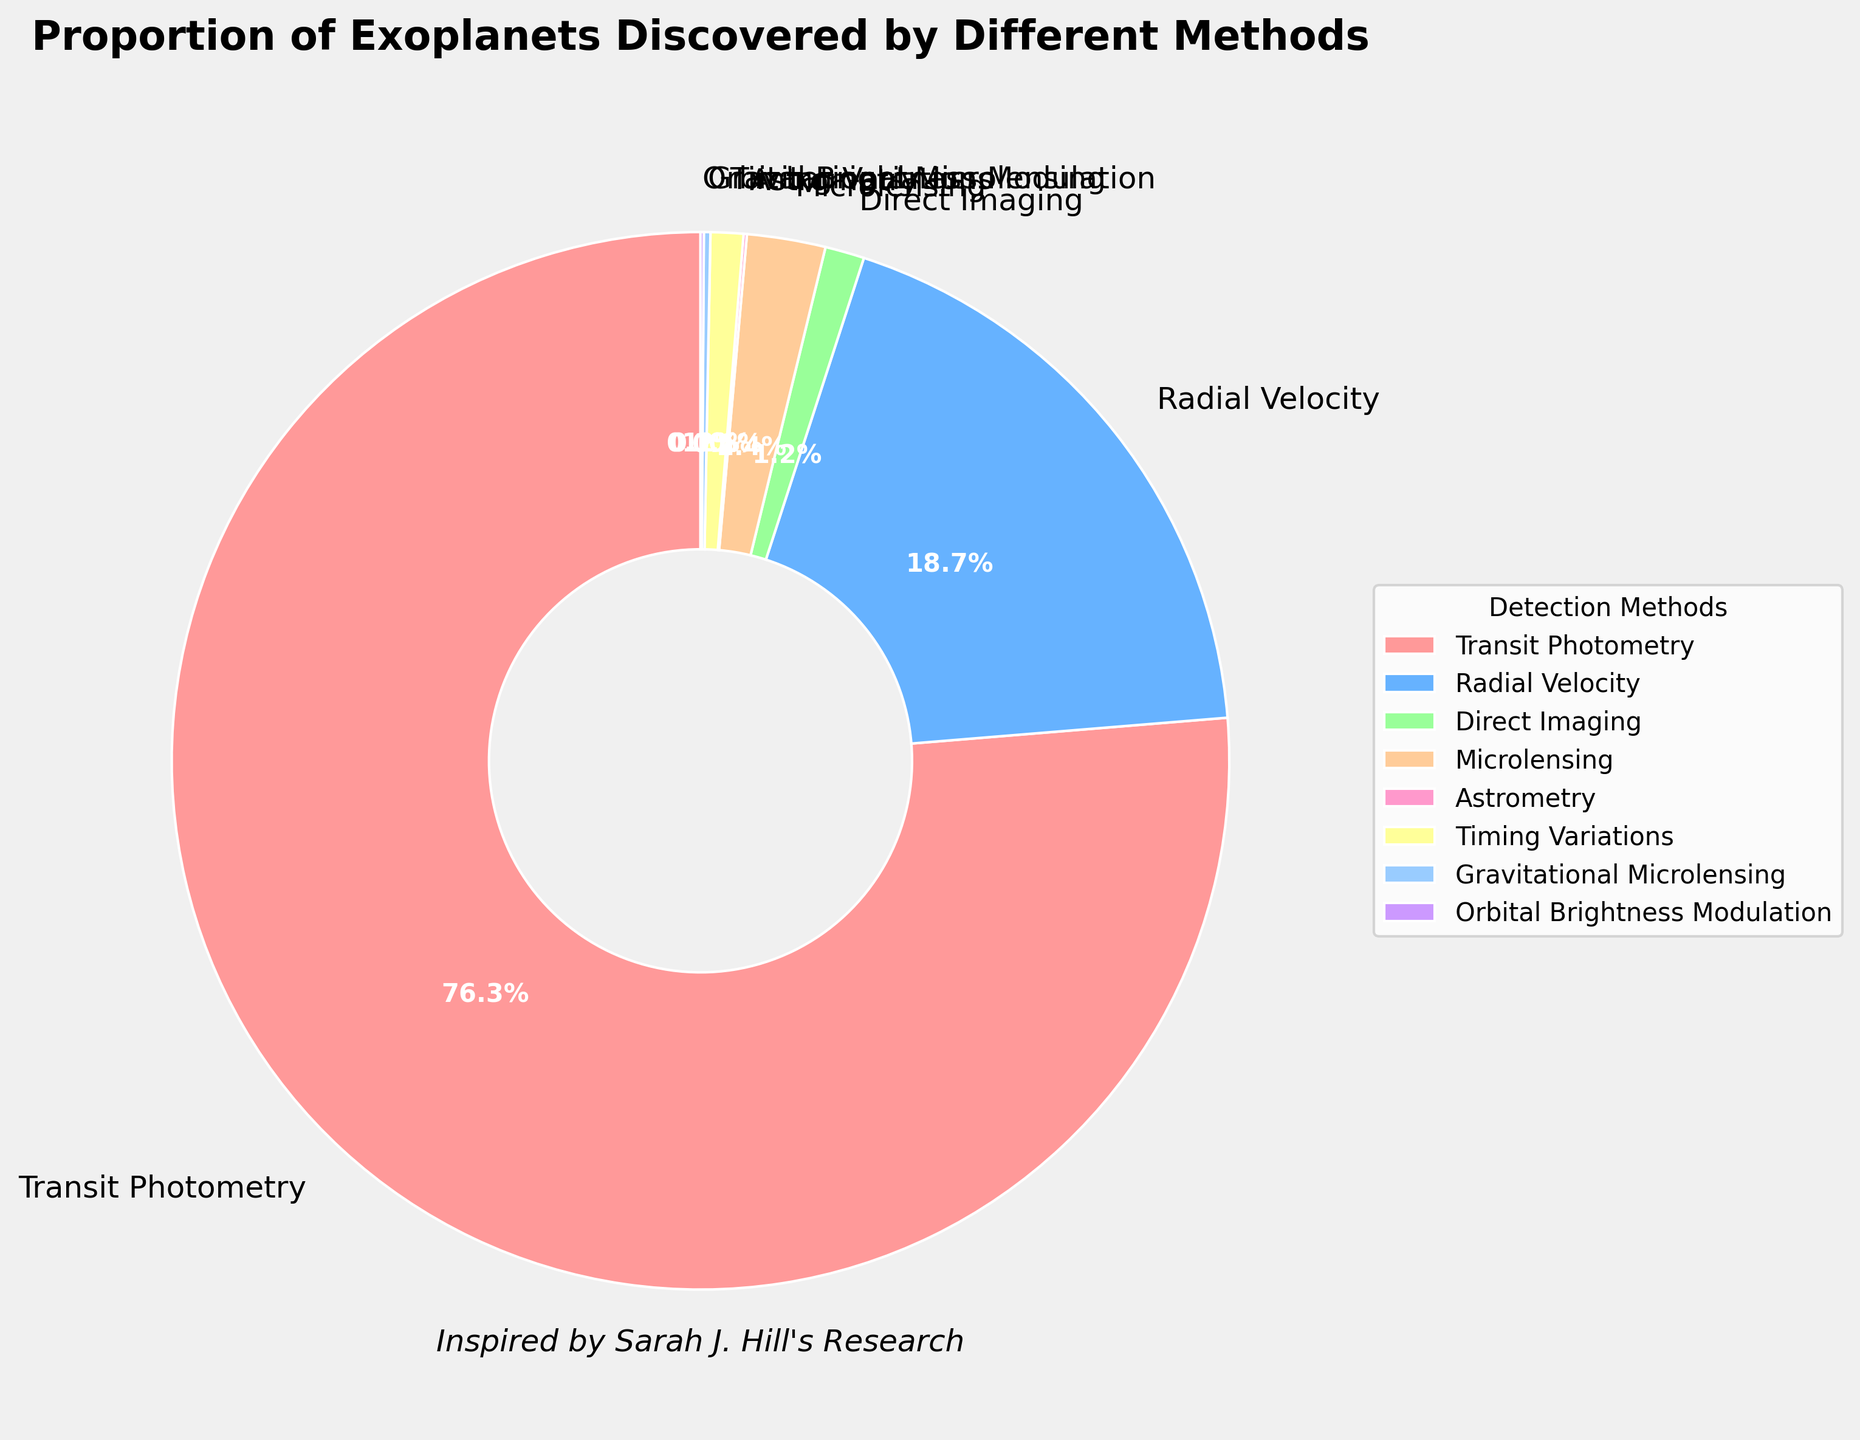what percentage of exoplanets are discovered using radial velocity compared to transit photometry? The pie chart shows that 76.3% of exoplanets are discovered using Transit Photometry, while 18.7% are discovered using Radial Velocity. To find the comparison, we see that Radial Velocity accounts for a far lesser percentage compared to Transit Photometry.
Answer: 18.7% vs 76.3% what are the two least common methods for discovering exoplanets? According to the pie chart, the smallest percentages are for Astrometry and Orbital Brightness Modulation, each accounting for only 0.1% of the discoveries.
Answer: Astrometry and Orbital Brightness Modulation what is the combined percentage of exoplanets discovered using microlensing and gravitational microlensing? The pie chart shows 2.4% of exoplanets discovered using microlensing and 0.2% using gravitational microlensing. Adding these two percentages gives us 2.4% + 0.2% = 2.6%.
Answer: 2.6% how much more common is transit photometry compared to direct imaging in discovering exoplanets? Transit Photometry is used for 76.3% of discoveries, while Direct Imaging is used for 1.2%. To find out how much more common Transit Photometry is, we subtract the smaller percentage from the larger one: 76.3% - 1.2% = 75.1%.
Answer: 75.1% which method is nearly as common as the combination of all other methods except transit photometry? Adding the percentages of all methods except Transit Photometry, we get 18.7% (Radial Velocity) + 1.2% (Direct Imaging) + 2.4% (Microlensing) + 0.1% (Astrometry) + 1.0% (Timing Variations) + 0.2% (Gravitational Microlensing) + 0.1% (Orbital Brightness Modulation) = 23.7%. As the individual method, Radial Velocity (18.7%) is nearly as common as this combination (23.7%).
Answer: Radial Velocity which detection methods together account for less than 1.5% of exoplanets discovered? Astrometry (0.1%), Timing Variations (1.0%), Gravitational Microlensing (0.2%), and Orbital Brightness Modulation (0.1%) all contribute percentages that sum less than 1.5%. Adding them together: 0.1% + 1.0% + 0.2% + 0.1% = 1.4%.
Answer: Astrometry, Timing Variations, Gravitational Microlensing, and Orbital Brightness Modulation 